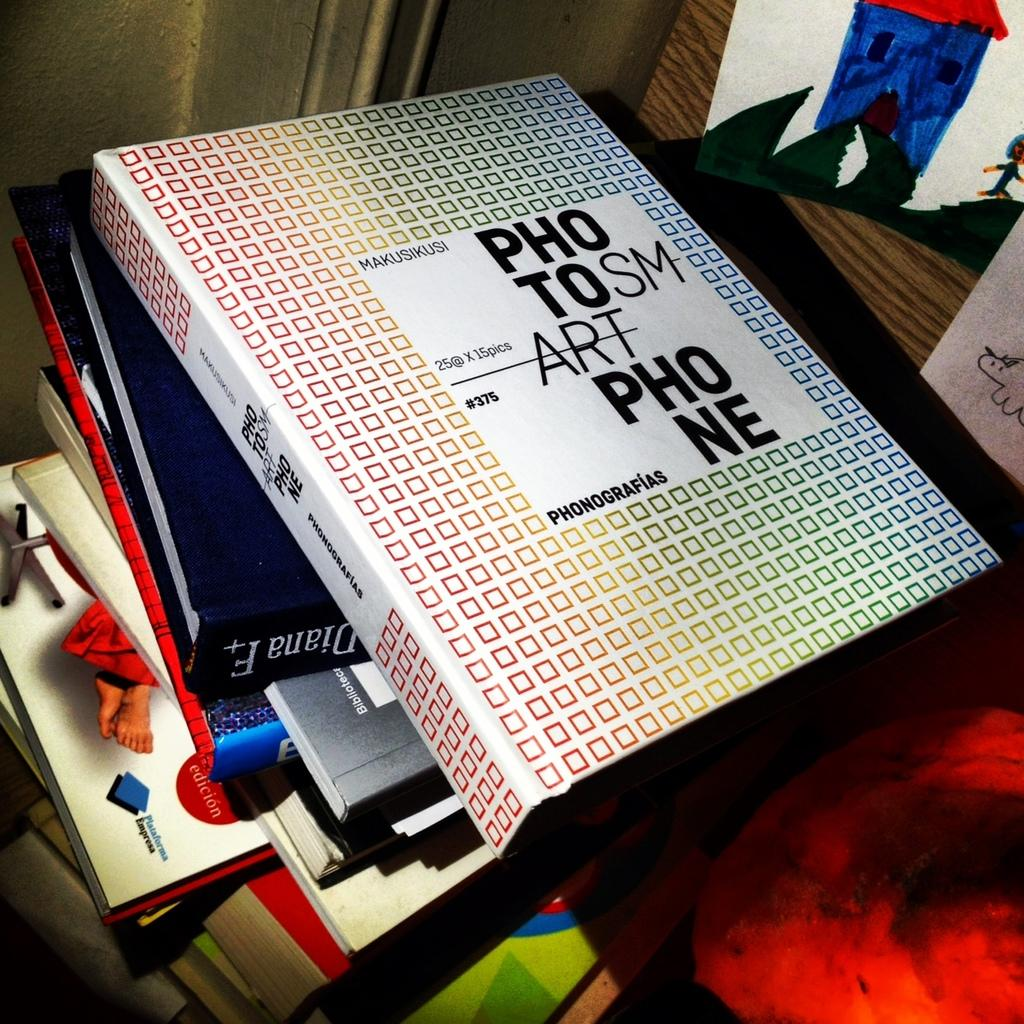<image>
Relay a brief, clear account of the picture shown. A stack of books with a binder on the top that Says PHO TOSM ART PHONE. 